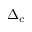Convert formula to latex. <formula><loc_0><loc_0><loc_500><loc_500>\Delta _ { c }</formula> 